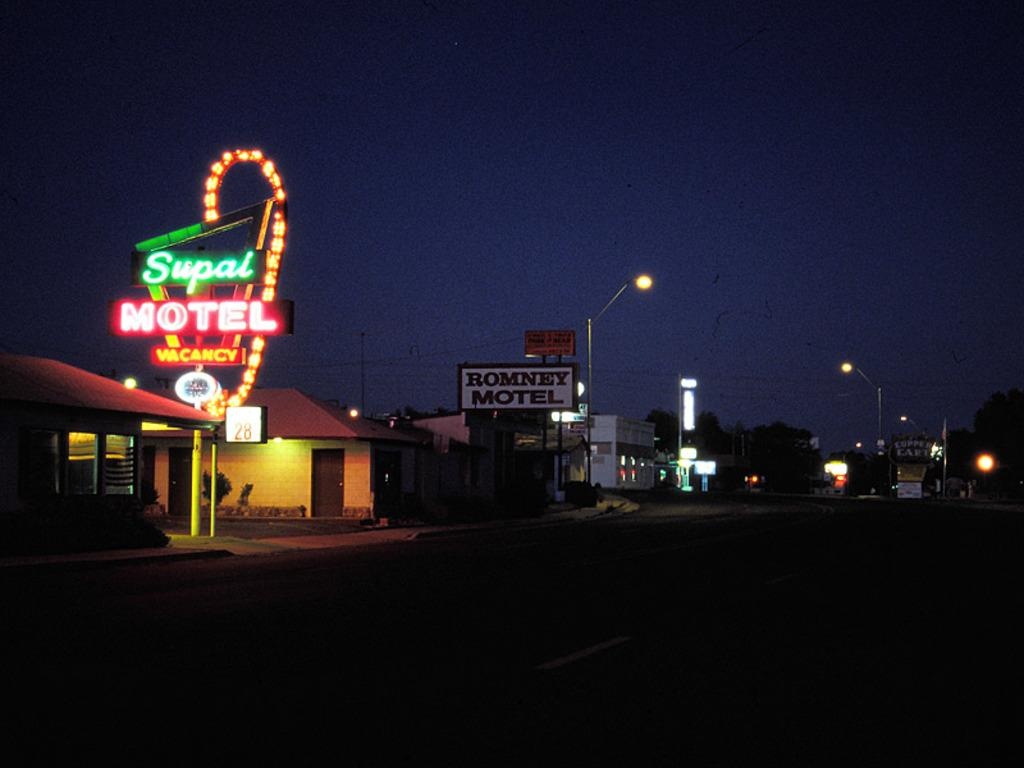What type of structures can be seen in the image? There are buildings in the image. What else can be seen on the electric poles in the image? Electric poles with lights are present in the image. What can be used for identification purposes in the image? Name boards are visible in the image. What type of vegetation is present in the image? Trees are present in the image. What other objects can be seen in the image besides buildings and trees? There are various objects in the image. What is visible in the background of the image? The sky is visible in the background of the image. Can you tell me how many letters your sister wrote to the person in the image? There is no mention of a sister or any letters in the image. What type of crime is being committed in the image? There is no indication of any crime being committed in the image. 